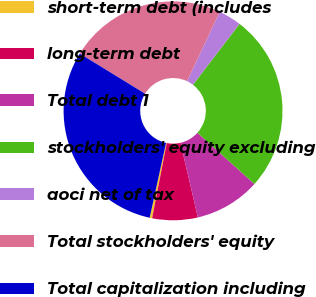<chart> <loc_0><loc_0><loc_500><loc_500><pie_chart><fcel>short-term debt (includes<fcel>long-term debt<fcel>Total debt 1<fcel>stockholders' equity excluding<fcel>aoci net of tax<fcel>Total stockholders' equity<fcel>Total capitalization including<nl><fcel>0.36%<fcel>6.71%<fcel>9.7%<fcel>26.27%<fcel>3.36%<fcel>23.27%<fcel>30.34%<nl></chart> 